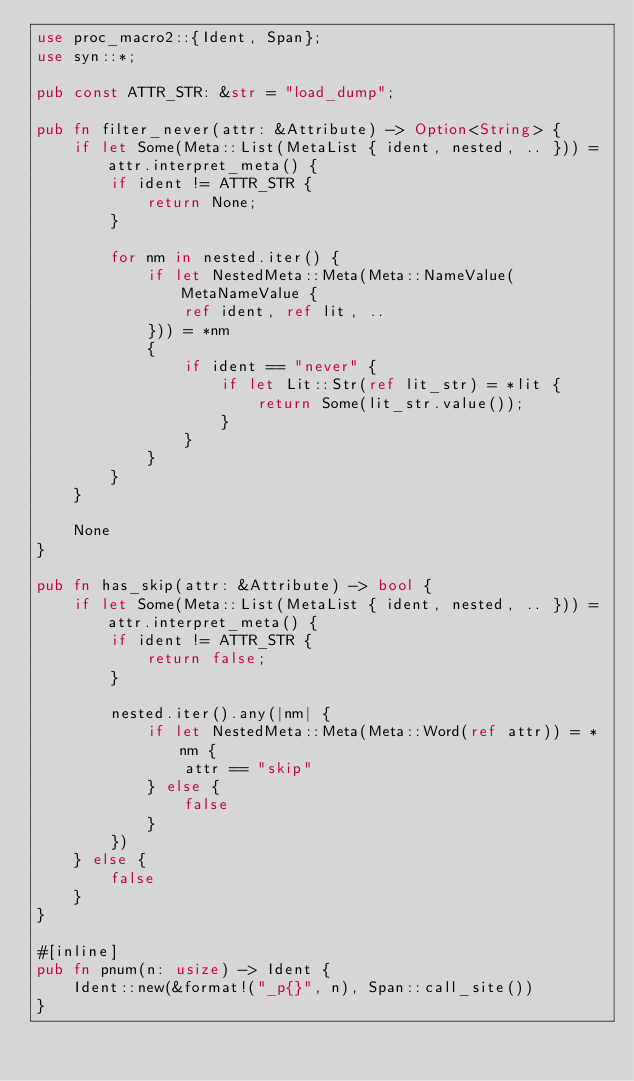Convert code to text. <code><loc_0><loc_0><loc_500><loc_500><_Rust_>use proc_macro2::{Ident, Span};
use syn::*;

pub const ATTR_STR: &str = "load_dump";

pub fn filter_never(attr: &Attribute) -> Option<String> {
    if let Some(Meta::List(MetaList { ident, nested, .. })) = attr.interpret_meta() {
        if ident != ATTR_STR {
            return None;
        }

        for nm in nested.iter() {
            if let NestedMeta::Meta(Meta::NameValue(MetaNameValue {
                ref ident, ref lit, ..
            })) = *nm
            {
                if ident == "never" {
                    if let Lit::Str(ref lit_str) = *lit {
                        return Some(lit_str.value());
                    }
                }
            }
        }
    }

    None
}

pub fn has_skip(attr: &Attribute) -> bool {
    if let Some(Meta::List(MetaList { ident, nested, .. })) = attr.interpret_meta() {
        if ident != ATTR_STR {
            return false;
        }

        nested.iter().any(|nm| {
            if let NestedMeta::Meta(Meta::Word(ref attr)) = *nm {
                attr == "skip"
            } else {
                false
            }
        })
    } else {
        false
    }
}

#[inline]
pub fn pnum(n: usize) -> Ident {
    Ident::new(&format!("_p{}", n), Span::call_site())
}
</code> 